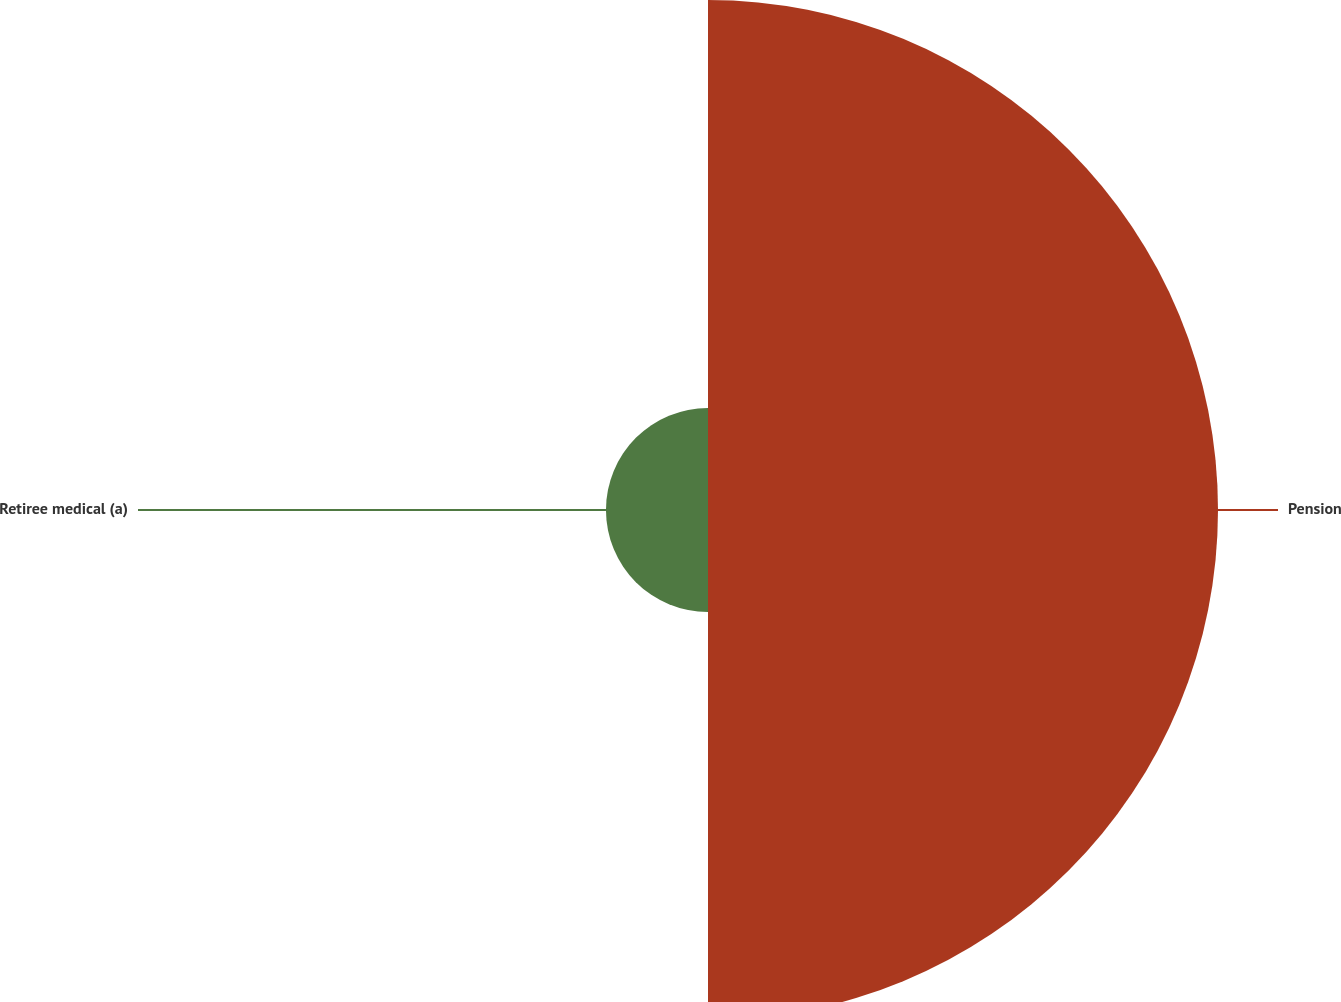Convert chart to OTSL. <chart><loc_0><loc_0><loc_500><loc_500><pie_chart><fcel>Pension<fcel>Retiree medical (a)<nl><fcel>83.33%<fcel>16.67%<nl></chart> 